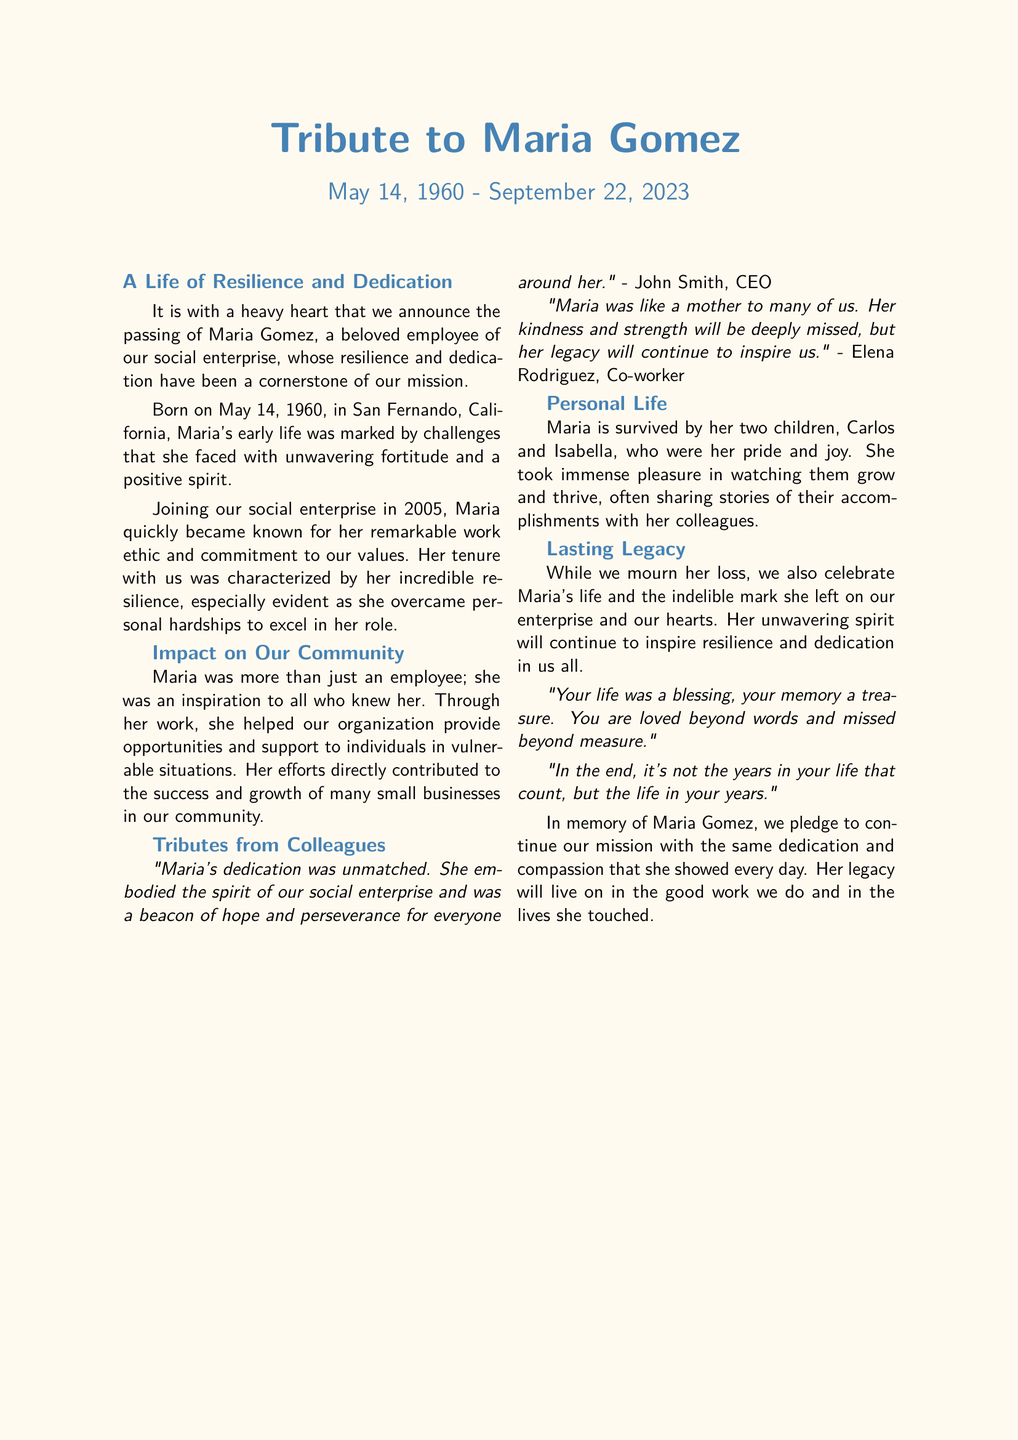What is the name of the employee being honored? The document states that the tribute is for Maria Gomez.
Answer: Maria Gomez What was Maria Gomez's date of birth? The document indicates that Maria was born on May 14, 1960.
Answer: May 14, 1960 What year did Maria join the social enterprise? According to the document, Maria joined the social enterprise in 2005.
Answer: 2005 How many children did Maria have? The document mentions that Maria is survived by two children.
Answer: Two Who is quoted as saying Maria was a beacon of hope? The CEO, John Smith, is quoted in the document about Maria.
Answer: John Smith What does the document say about Maria's impact on the community? It states that she helped the organization provide opportunities and support to individuals.
Answer: Opportunities and support What does the document pledge in memory of Maria? The document pledges to continue their mission with dedication and compassion.
Answer: Continue the mission What is the main theme of Maria's personal life as presented? The document emphasizes her pride in her children and joy in their accomplishments.
Answer: Pride and joy What does the last quote in the document emphasize? The last quote discusses the importance of the life lived rather than the years counted.
Answer: Life lived over years counted 